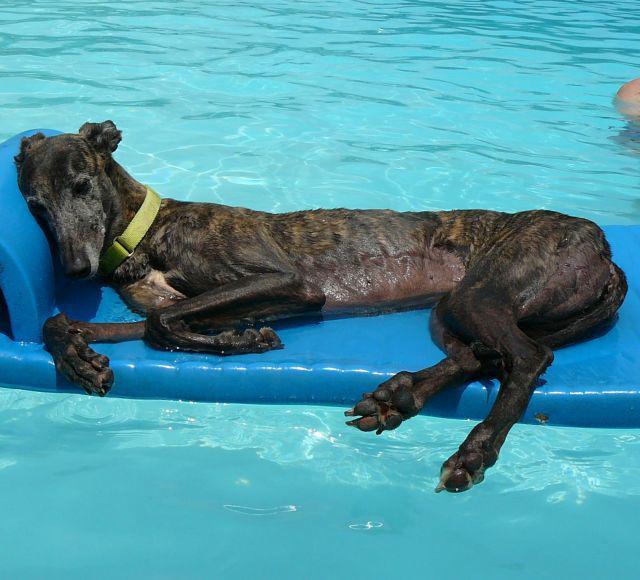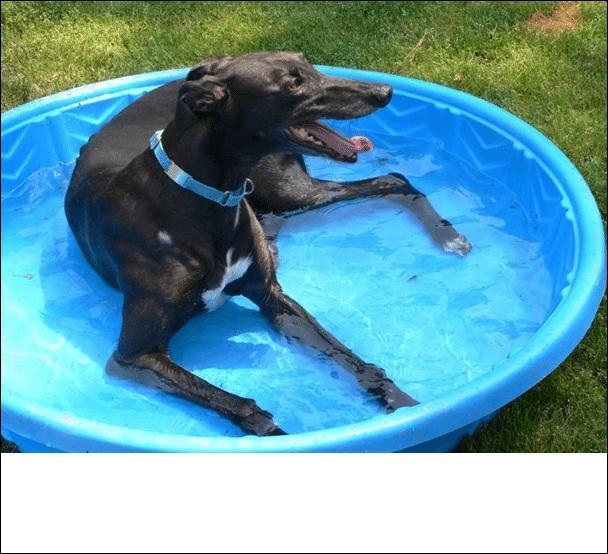The first image is the image on the left, the second image is the image on the right. Assess this claim about the two images: "there is a dog laying in a baby pool in the right image". Correct or not? Answer yes or no. Yes. The first image is the image on the left, the second image is the image on the right. Evaluate the accuracy of this statement regarding the images: "At least one dog with dark fur is lying down in a small pool.". Is it true? Answer yes or no. Yes. 